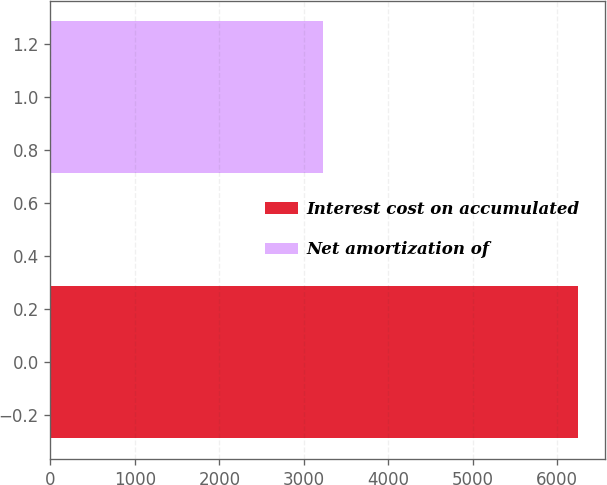<chart> <loc_0><loc_0><loc_500><loc_500><bar_chart><fcel>Interest cost on accumulated<fcel>Net amortization of<nl><fcel>6251<fcel>3233<nl></chart> 